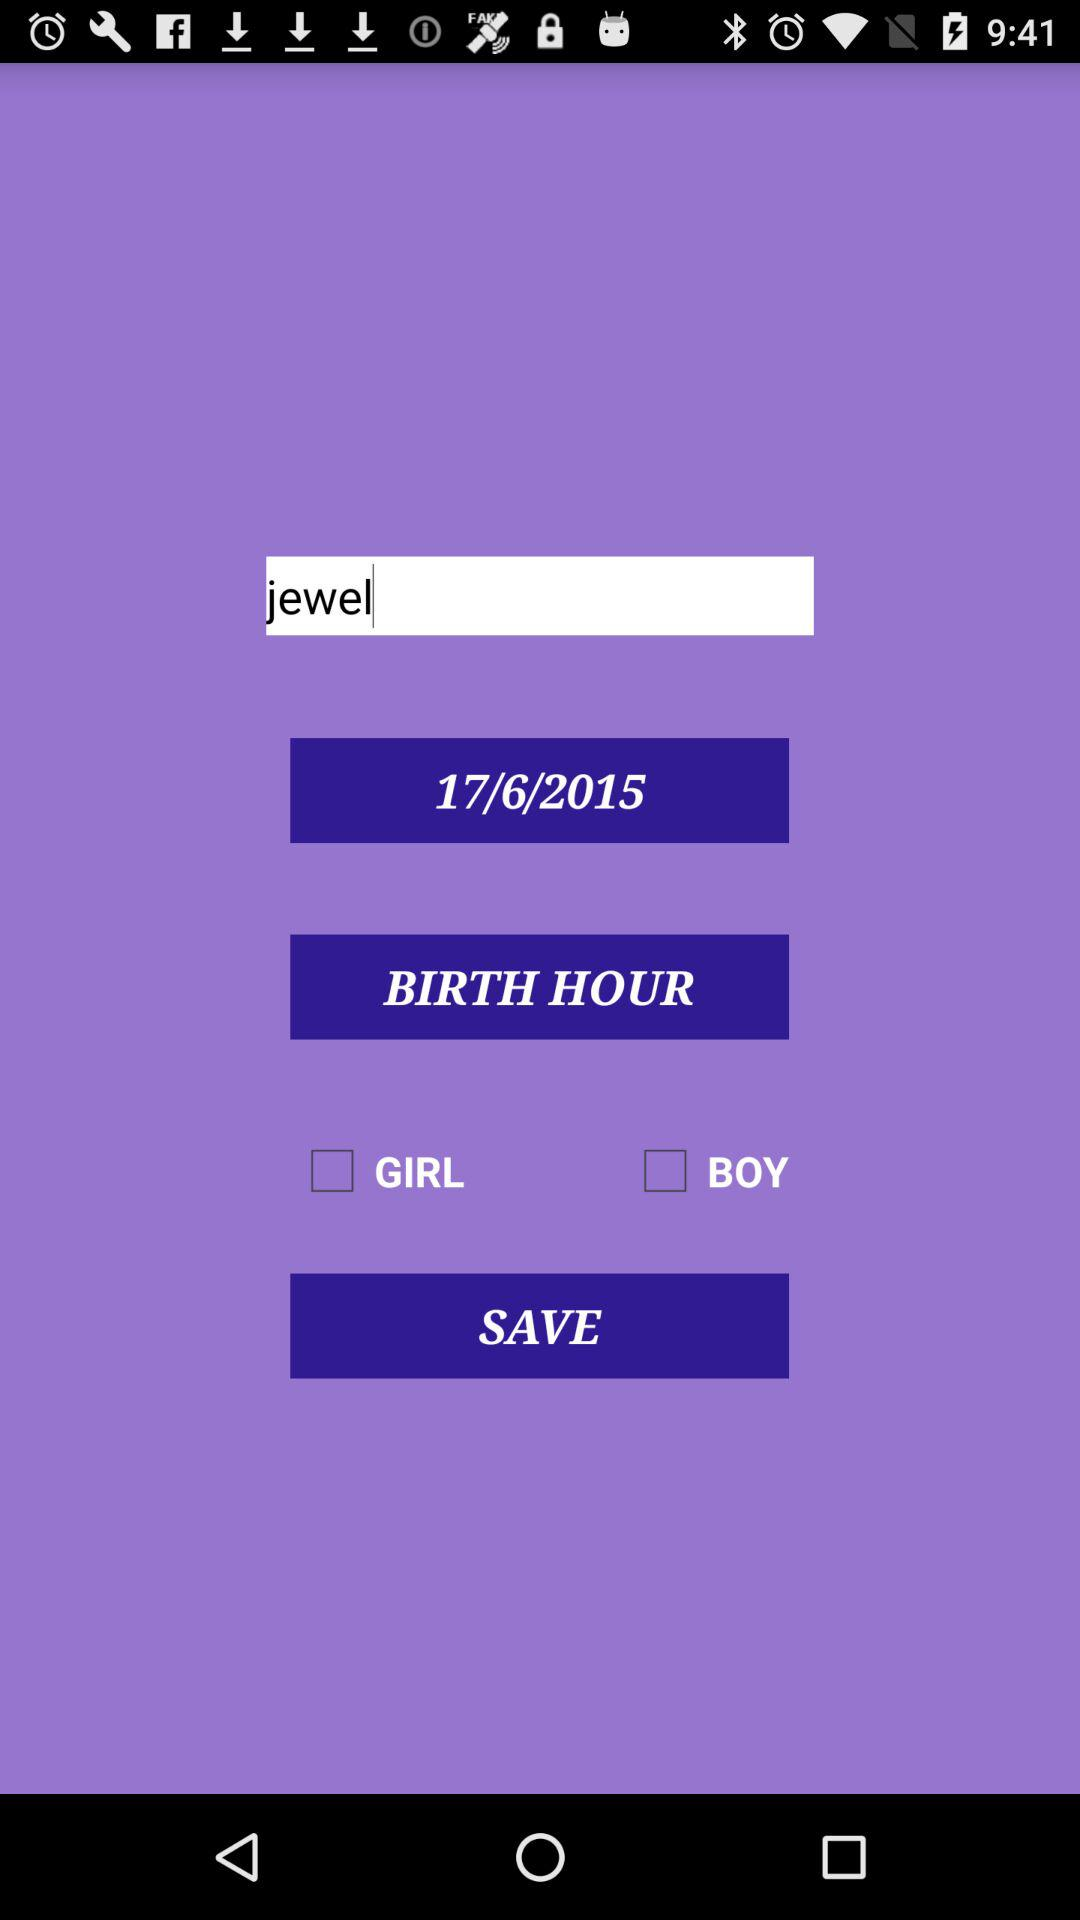What is the user name? The user name is Jewel. 